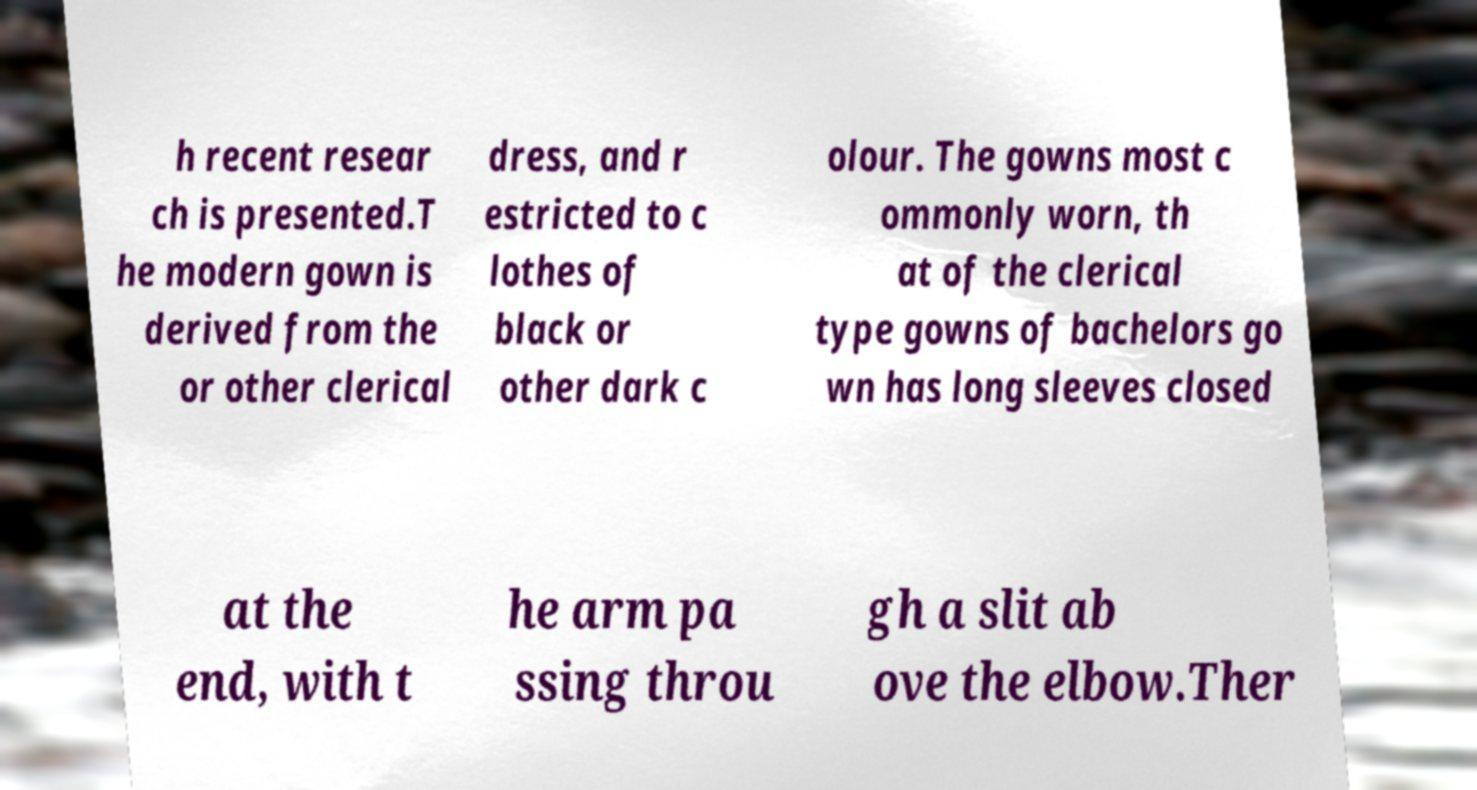Could you extract and type out the text from this image? h recent resear ch is presented.T he modern gown is derived from the or other clerical dress, and r estricted to c lothes of black or other dark c olour. The gowns most c ommonly worn, th at of the clerical type gowns of bachelors go wn has long sleeves closed at the end, with t he arm pa ssing throu gh a slit ab ove the elbow.Ther 